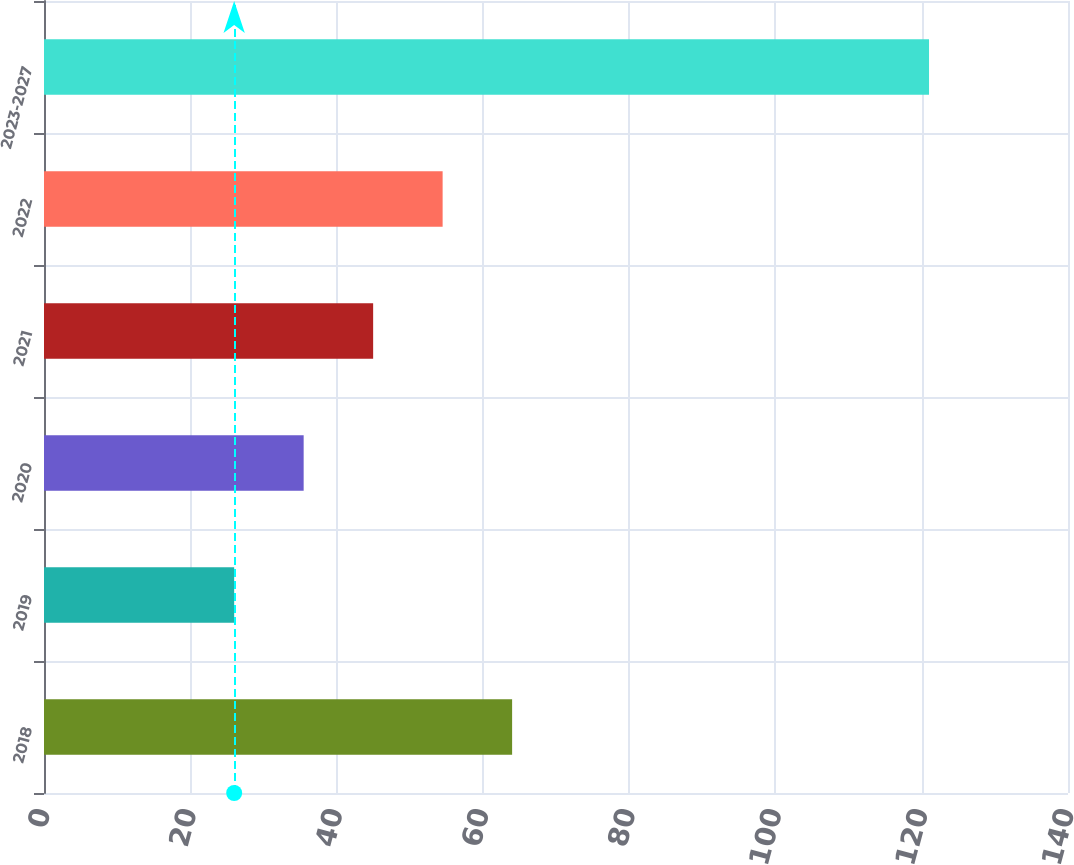<chart> <loc_0><loc_0><loc_500><loc_500><bar_chart><fcel>2018<fcel>2019<fcel>2020<fcel>2021<fcel>2022<fcel>2023-2027<nl><fcel>64<fcel>26<fcel>35.5<fcel>45<fcel>54.5<fcel>121<nl></chart> 